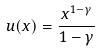Convert formula to latex. <formula><loc_0><loc_0><loc_500><loc_500>u ( x ) = \frac { x ^ { 1 - \gamma } } { 1 - \gamma }</formula> 